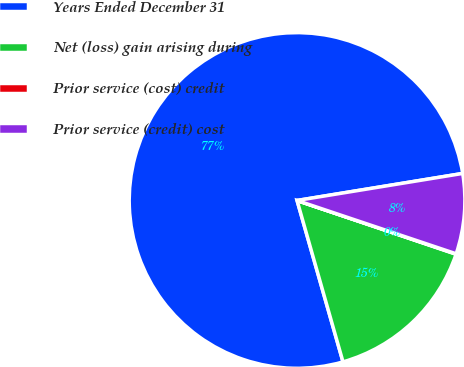Convert chart to OTSL. <chart><loc_0><loc_0><loc_500><loc_500><pie_chart><fcel>Years Ended December 31<fcel>Net (loss) gain arising during<fcel>Prior service (cost) credit<fcel>Prior service (credit) cost<nl><fcel>76.84%<fcel>15.4%<fcel>0.04%<fcel>7.72%<nl></chart> 